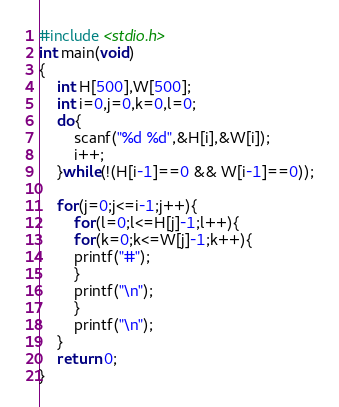Convert code to text. <code><loc_0><loc_0><loc_500><loc_500><_C_>#include <stdio.h> 
int main(void)
{
	int H[500],W[500];
	int i=0,j=0,k=0,l=0;
	do{
		scanf("%d %d",&H[i],&W[i]);
		i++;
	}while(!(H[i-1]==0 && W[i-1]==0));
	
	for(j=0;j<=i-1;j++){
		for(l=0;l<=H[j]-1;l++){
		for(k=0;k<=W[j]-1;k++){
		printf("#");
		}
		printf("\n");
		}
		printf("\n");
	}
	return 0;
}</code> 